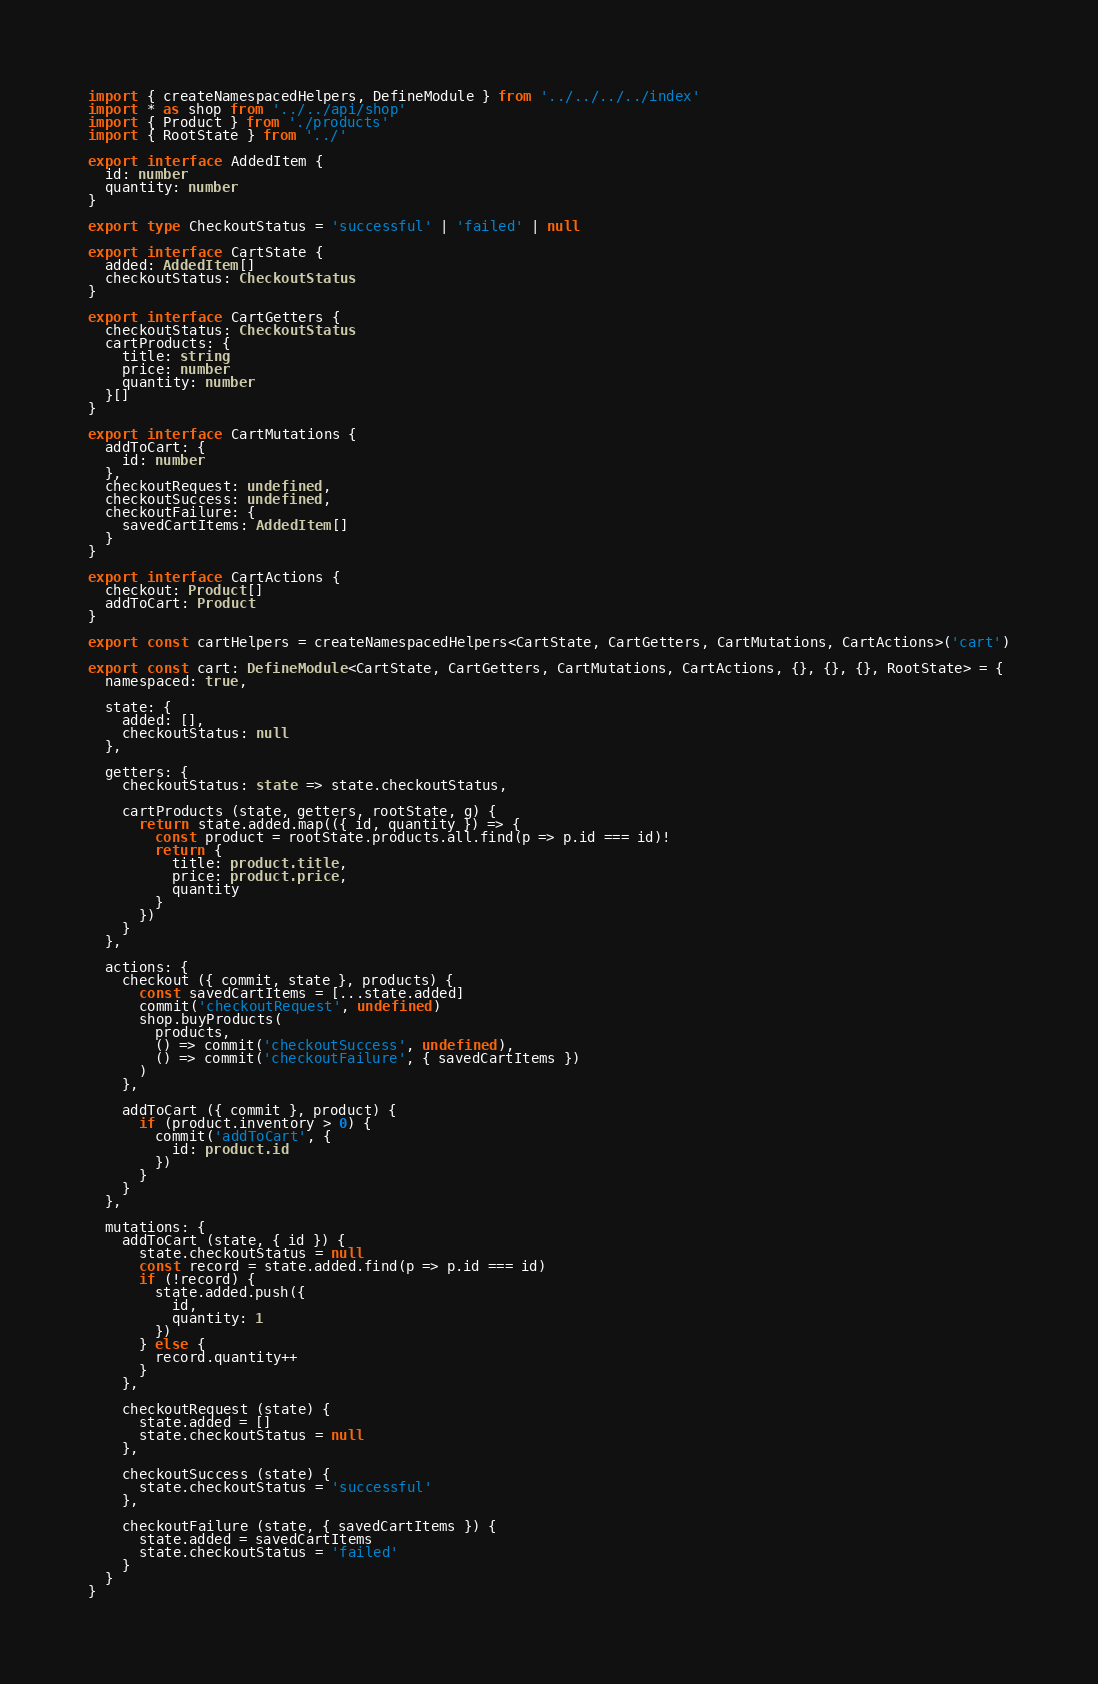<code> <loc_0><loc_0><loc_500><loc_500><_TypeScript_>import { createNamespacedHelpers, DefineModule } from '../../../../index'
import * as shop from '../../api/shop'
import { Product } from './products'
import { RootState } from '../'

export interface AddedItem {
  id: number
  quantity: number
}

export type CheckoutStatus = 'successful' | 'failed' | null

export interface CartState {
  added: AddedItem[]
  checkoutStatus: CheckoutStatus
}

export interface CartGetters {
  checkoutStatus: CheckoutStatus
  cartProducts: {
    title: string
    price: number
    quantity: number
  }[]
}

export interface CartMutations {
  addToCart: {
    id: number
  },
  checkoutRequest: undefined,
  checkoutSuccess: undefined,
  checkoutFailure: {
    savedCartItems: AddedItem[]
  }
}

export interface CartActions {
  checkout: Product[]
  addToCart: Product
}

export const cartHelpers = createNamespacedHelpers<CartState, CartGetters, CartMutations, CartActions>('cart')

export const cart: DefineModule<CartState, CartGetters, CartMutations, CartActions, {}, {}, {}, RootState> = {
  namespaced: true,

  state: {
    added: [],
    checkoutStatus: null
  },

  getters: {
    checkoutStatus: state => state.checkoutStatus,

    cartProducts (state, getters, rootState, g) {
      return state.added.map(({ id, quantity }) => {
        const product = rootState.products.all.find(p => p.id === id)!
        return {
          title: product.title,
          price: product.price,
          quantity
        }
      })
    }
  },

  actions: {
    checkout ({ commit, state }, products) {
      const savedCartItems = [...state.added]
      commit('checkoutRequest', undefined)
      shop.buyProducts(
        products,
        () => commit('checkoutSuccess', undefined),
        () => commit('checkoutFailure', { savedCartItems })
      )
    },

    addToCart ({ commit }, product) {
      if (product.inventory > 0) {
        commit('addToCart', {
          id: product.id
        })
      }
    }
  },

  mutations: {
    addToCart (state, { id }) {
      state.checkoutStatus = null
      const record = state.added.find(p => p.id === id)
      if (!record) {
        state.added.push({
          id,
          quantity: 1
        })
      } else {
        record.quantity++
      }
    },

    checkoutRequest (state) {
      state.added = []
      state.checkoutStatus = null
    },

    checkoutSuccess (state) {
      state.checkoutStatus = 'successful'
    },

    checkoutFailure (state, { savedCartItems }) {
      state.added = savedCartItems
      state.checkoutStatus = 'failed'
    }
  }
}
</code> 